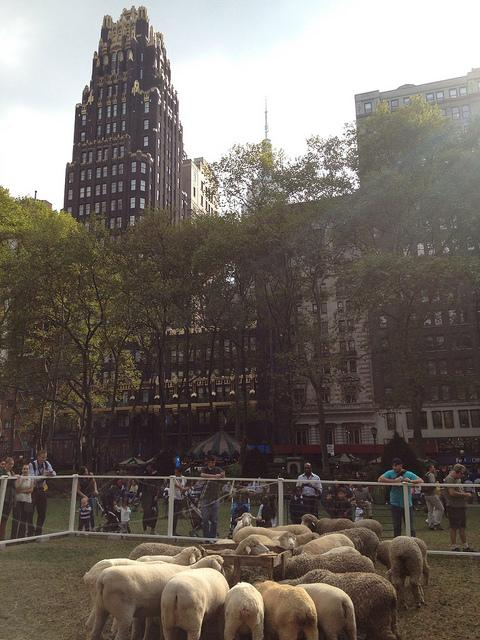What structure surrounds the animals? fence 